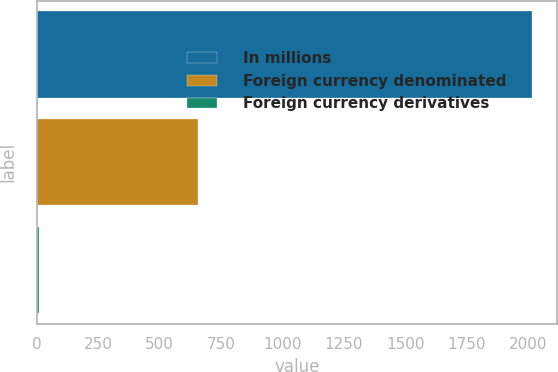Convert chart to OTSL. <chart><loc_0><loc_0><loc_500><loc_500><bar_chart><fcel>In millions<fcel>Foreign currency denominated<fcel>Foreign currency derivatives<nl><fcel>2016<fcel>654.9<fcel>9.9<nl></chart> 